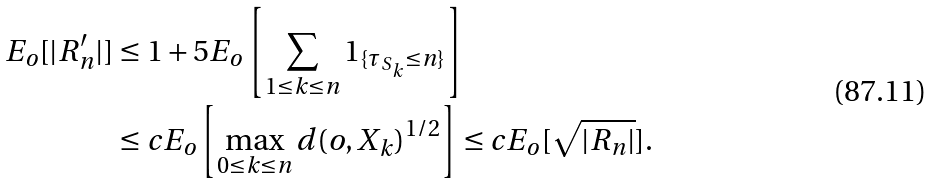Convert formula to latex. <formula><loc_0><loc_0><loc_500><loc_500>E _ { o } [ | R _ { n } ^ { \prime } | ] & \leq 1 + 5 E _ { o } \left [ \sum _ { 1 \leq k \leq n } { 1 } _ { \{ \tau _ { S _ { k } } \leq n \} } \right ] \\ & \leq c E _ { o } \left [ \max _ { 0 \leq k \leq n } d ( o , X _ { k } ) ^ { 1 / 2 } \right ] \leq c E _ { o } [ \sqrt { | R _ { n } | } ] .</formula> 